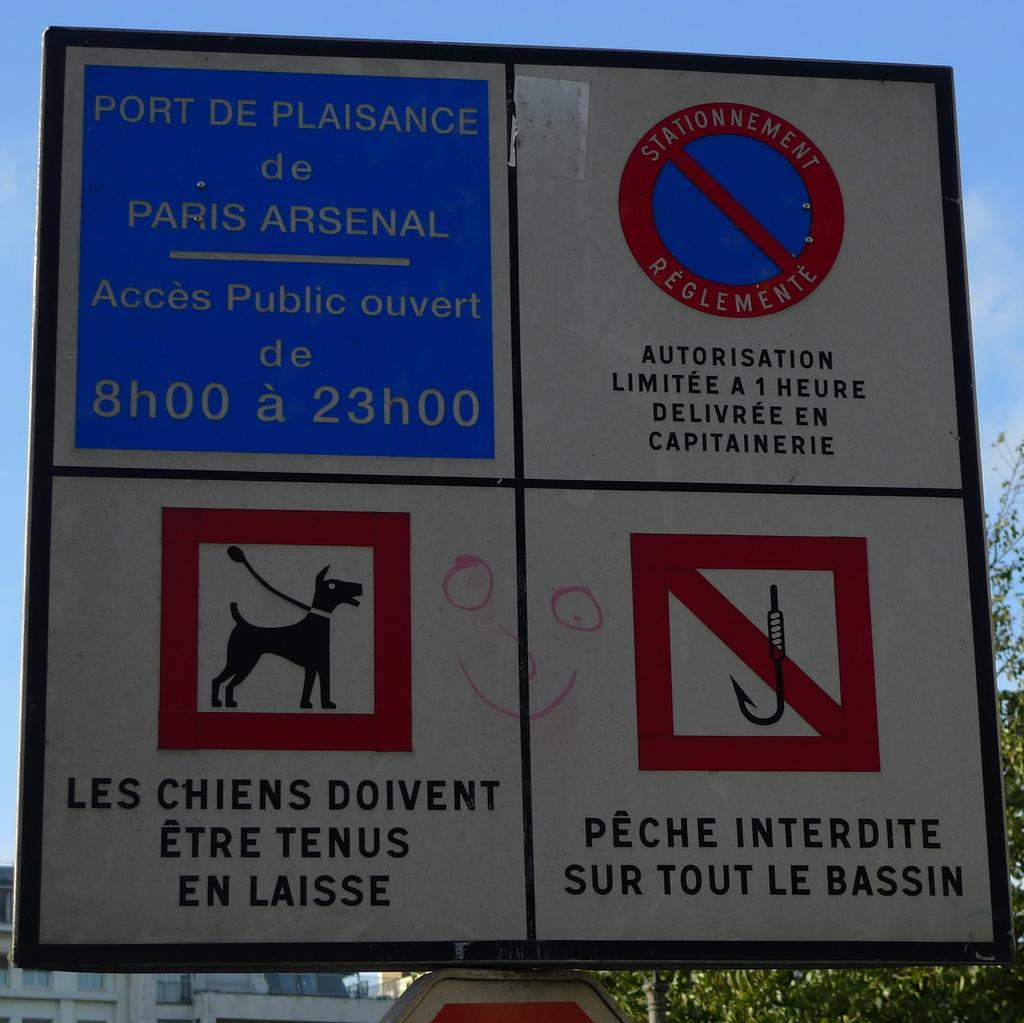What is located in the foreground of the image? There is a board in the foreground of the image. What can be seen on the board? There is text on the board. What is visible in the background of the image? There are buildings and trees in the background of the image. What is visible at the top of the image? The sky is visible at the top of the image. Can you see the sea in the background of the image? No, there is no sea visible in the image. The background features buildings and trees. 